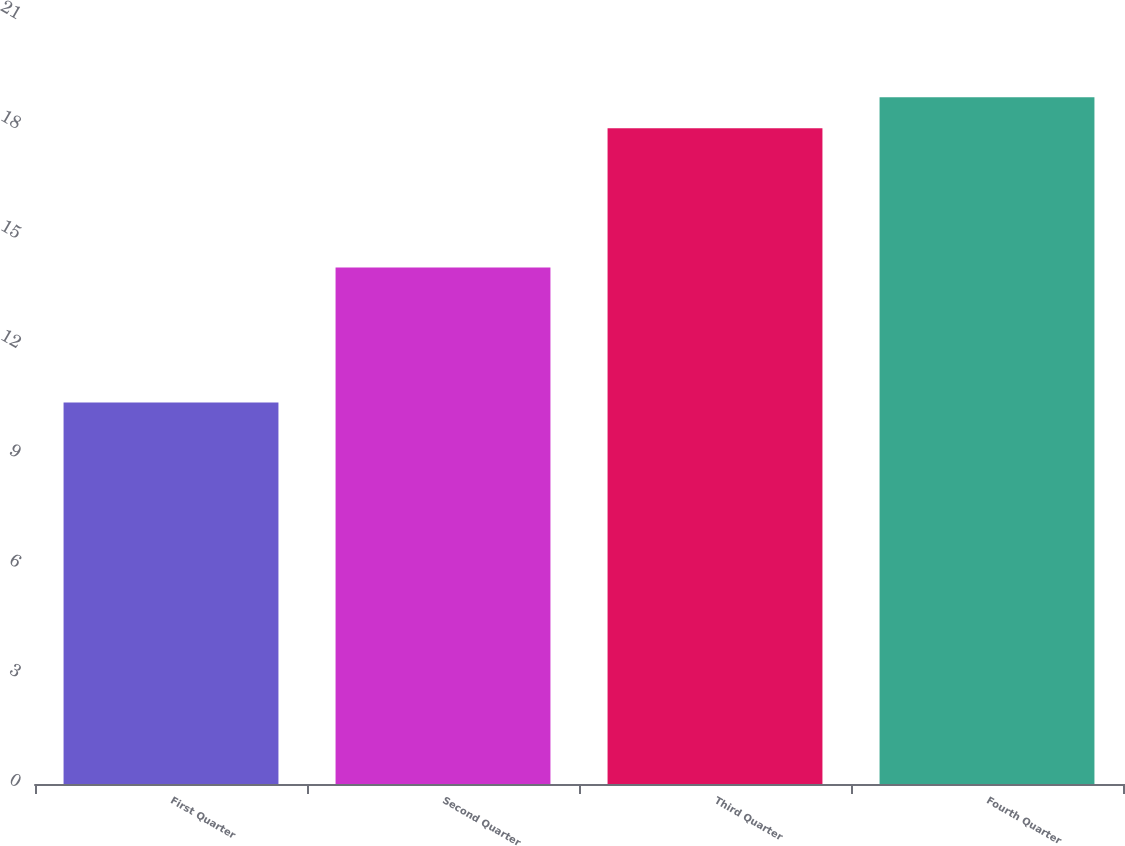Convert chart. <chart><loc_0><loc_0><loc_500><loc_500><bar_chart><fcel>First Quarter<fcel>Second Quarter<fcel>Third Quarter<fcel>Fourth Quarter<nl><fcel>10.43<fcel>14.12<fcel>17.93<fcel>18.78<nl></chart> 